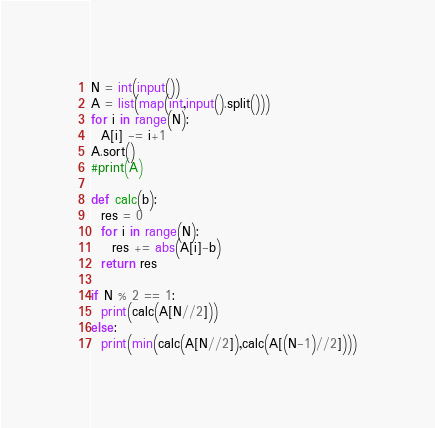<code> <loc_0><loc_0><loc_500><loc_500><_Python_>N = int(input())
A = list(map(int,input().split()))
for i in range(N):
  A[i] -= i+1
A.sort()
#print(A)

def calc(b):
  res = 0
  for i in range(N):
    res += abs(A[i]-b)
  return res

if N % 2 == 1:
  print(calc(A[N//2]))
else:
  print(min(calc(A[N//2]),calc(A[(N-1)//2])))
</code> 